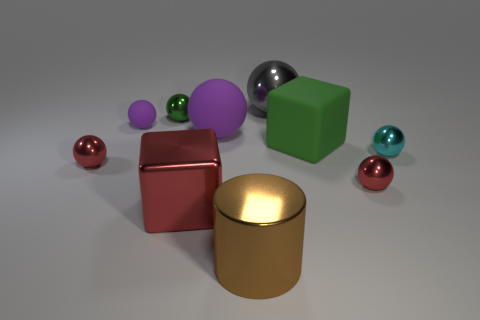Subtract all purple blocks. How many purple spheres are left? 2 Subtract all big purple rubber spheres. How many spheres are left? 6 Subtract all green spheres. How many spheres are left? 6 Subtract all cubes. How many objects are left? 8 Subtract all green spheres. Subtract all brown cylinders. How many spheres are left? 6 Add 5 green matte blocks. How many green matte blocks exist? 6 Subtract 0 blue cylinders. How many objects are left? 10 Subtract all small green balls. Subtract all gray shiny spheres. How many objects are left? 8 Add 8 tiny purple rubber balls. How many tiny purple rubber balls are left? 9 